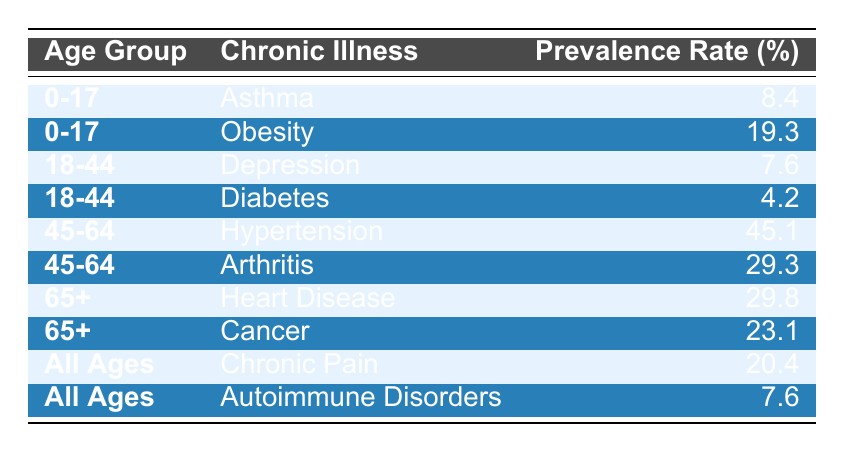What is the prevalence rate of asthma in the age group 0-17? The table lists asthma under the age group 0-17 with a prevalence rate of 8.4%.
Answer: 8.4% Which chronic illness has the highest prevalence rate in the age group 45-64? In the age group 45-64, hypertension has the highest prevalence rate at 45.1%, as indicated in the table.
Answer: Hypertension Is the prevalence rate of diabetes in the age group 18-44 higher than that of depression? The prevalence rate of diabetes is 4.2% and the rate of depression is 7.6%. Since 4.2% is less than 7.6%, the statement is false.
Answer: No What is the total prevalence rate of chronic illnesses for the age group 65+? The prevalence rates for 65+ are heart disease at 29.8% and cancer at 23.1%. Adding these rates together gives 29.8% + 23.1% = 52.9%.
Answer: 52.9% Which age group has a prevalence rate of obesity, and what is that rate? The age group for obesity is 0-17 with a prevalence rate of 19.3% as shown in the table.
Answer: 0-17: 19.3% Is there a chronic illness that affects all ages? The table indicates that both chronic pain and autoimmune disorders are categorized under 'All Ages.' Thus, this statement is true.
Answer: Yes What is the difference in prevalence rates between arthritis and chronic pain? Arthritis has a prevalence rate of 29.3% and chronic pain has a rate of 20.4%. The difference is a subtraction of these values: 29.3% - 20.4% = 8.9%.
Answer: 8.9% What chronic illness has the lowest prevalence rate in the age group 18-44? Among the illnesses listed under the age group 18-44, diabetes has the lowest prevalence rate at 4.2%, based on the table information.
Answer: Diabetes What is the average prevalence rate of the chronic illnesses listed for the age group 45-64? The rates for 45-64 are hypertension (45.1%) and arthritis (29.3%). The average is calculated as (45.1% + 29.3%) / 2 = 37.2%.
Answer: 37.2% 